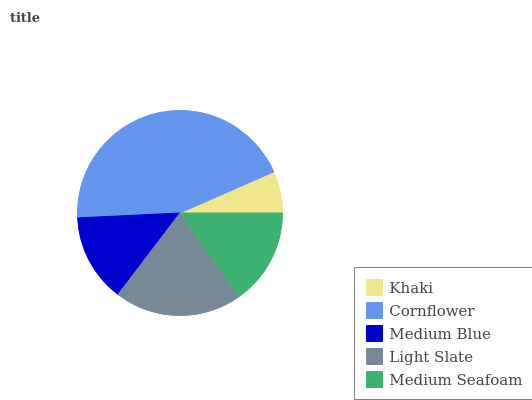Is Khaki the minimum?
Answer yes or no. Yes. Is Cornflower the maximum?
Answer yes or no. Yes. Is Medium Blue the minimum?
Answer yes or no. No. Is Medium Blue the maximum?
Answer yes or no. No. Is Cornflower greater than Medium Blue?
Answer yes or no. Yes. Is Medium Blue less than Cornflower?
Answer yes or no. Yes. Is Medium Blue greater than Cornflower?
Answer yes or no. No. Is Cornflower less than Medium Blue?
Answer yes or no. No. Is Medium Seafoam the high median?
Answer yes or no. Yes. Is Medium Seafoam the low median?
Answer yes or no. Yes. Is Khaki the high median?
Answer yes or no. No. Is Medium Blue the low median?
Answer yes or no. No. 